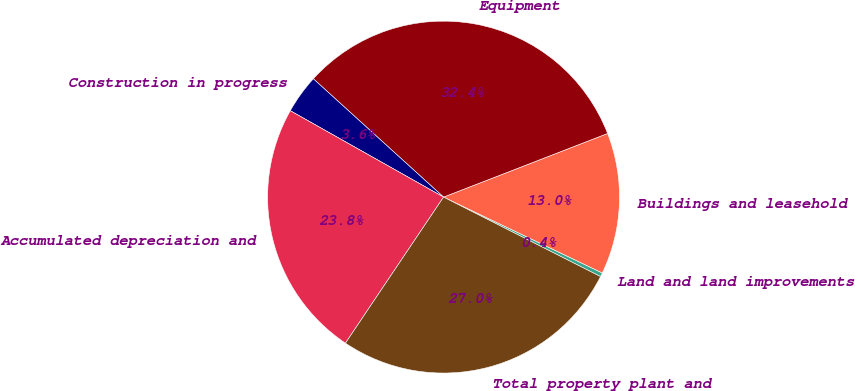Convert chart to OTSL. <chart><loc_0><loc_0><loc_500><loc_500><pie_chart><fcel>Land and land improvements<fcel>Buildings and leasehold<fcel>Equipment<fcel>Construction in progress<fcel>Accumulated depreciation and<fcel>Total property plant and<nl><fcel>0.37%<fcel>12.98%<fcel>32.37%<fcel>3.57%<fcel>23.75%<fcel>26.95%<nl></chart> 